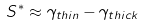Convert formula to latex. <formula><loc_0><loc_0><loc_500><loc_500>S ^ { * } \approx \gamma _ { t h i n } - \gamma _ { t h i c k }</formula> 